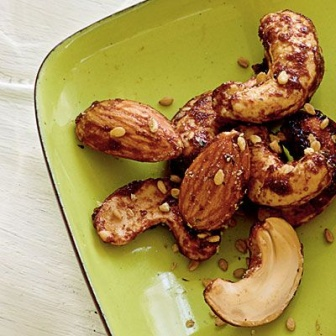Can you describe the plate and its surroundings in detail? The green plate featured in the image is square with gently rounded edges and a smooth, glossy finish that reflects light, emphasizing its soothing color. This vibrant green backdrop provides a striking contrast to the roasted nuts on the plate. The plate is placed on a white wooden surface, which offers a rustic, natural charm to the overall setting. The white surface has a slightly worn texture with visible wood grain, adding layers of authenticity and warmth to the scene. The light catches on the oil-glazed nuts, making the entire setup appear fresh and inviting, reminiscent of homely kitchen settings where such delightful treats are often prepared and enjoyed. 